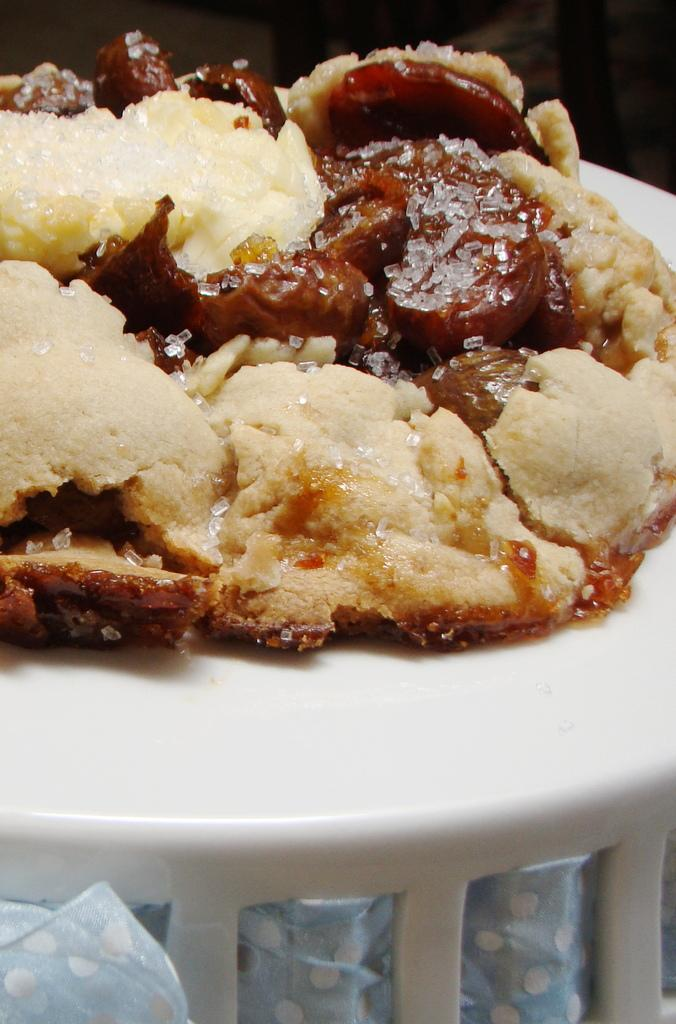What is on the plate that is visible in the image? There is a chocolate cake on the plate. What color is the plate in the image? The plate is white. What is being added to the cake in the image? Sugar is being sprinkled on the cake. What channel is the crow watching on the monkey's television in the image? There is no television, crow, or monkey present in the image. 